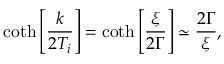Convert formula to latex. <formula><loc_0><loc_0><loc_500><loc_500>\coth \left [ \frac { k } { 2 T _ { i } } \right ] = \coth \left [ \frac { \xi } { 2 \Gamma } \right ] \simeq \frac { 2 \Gamma } { \xi } ,</formula> 